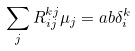Convert formula to latex. <formula><loc_0><loc_0><loc_500><loc_500>\sum _ { j } R ^ { k j } _ { i j } \mu _ { j } = a b \delta ^ { k } _ { i }</formula> 